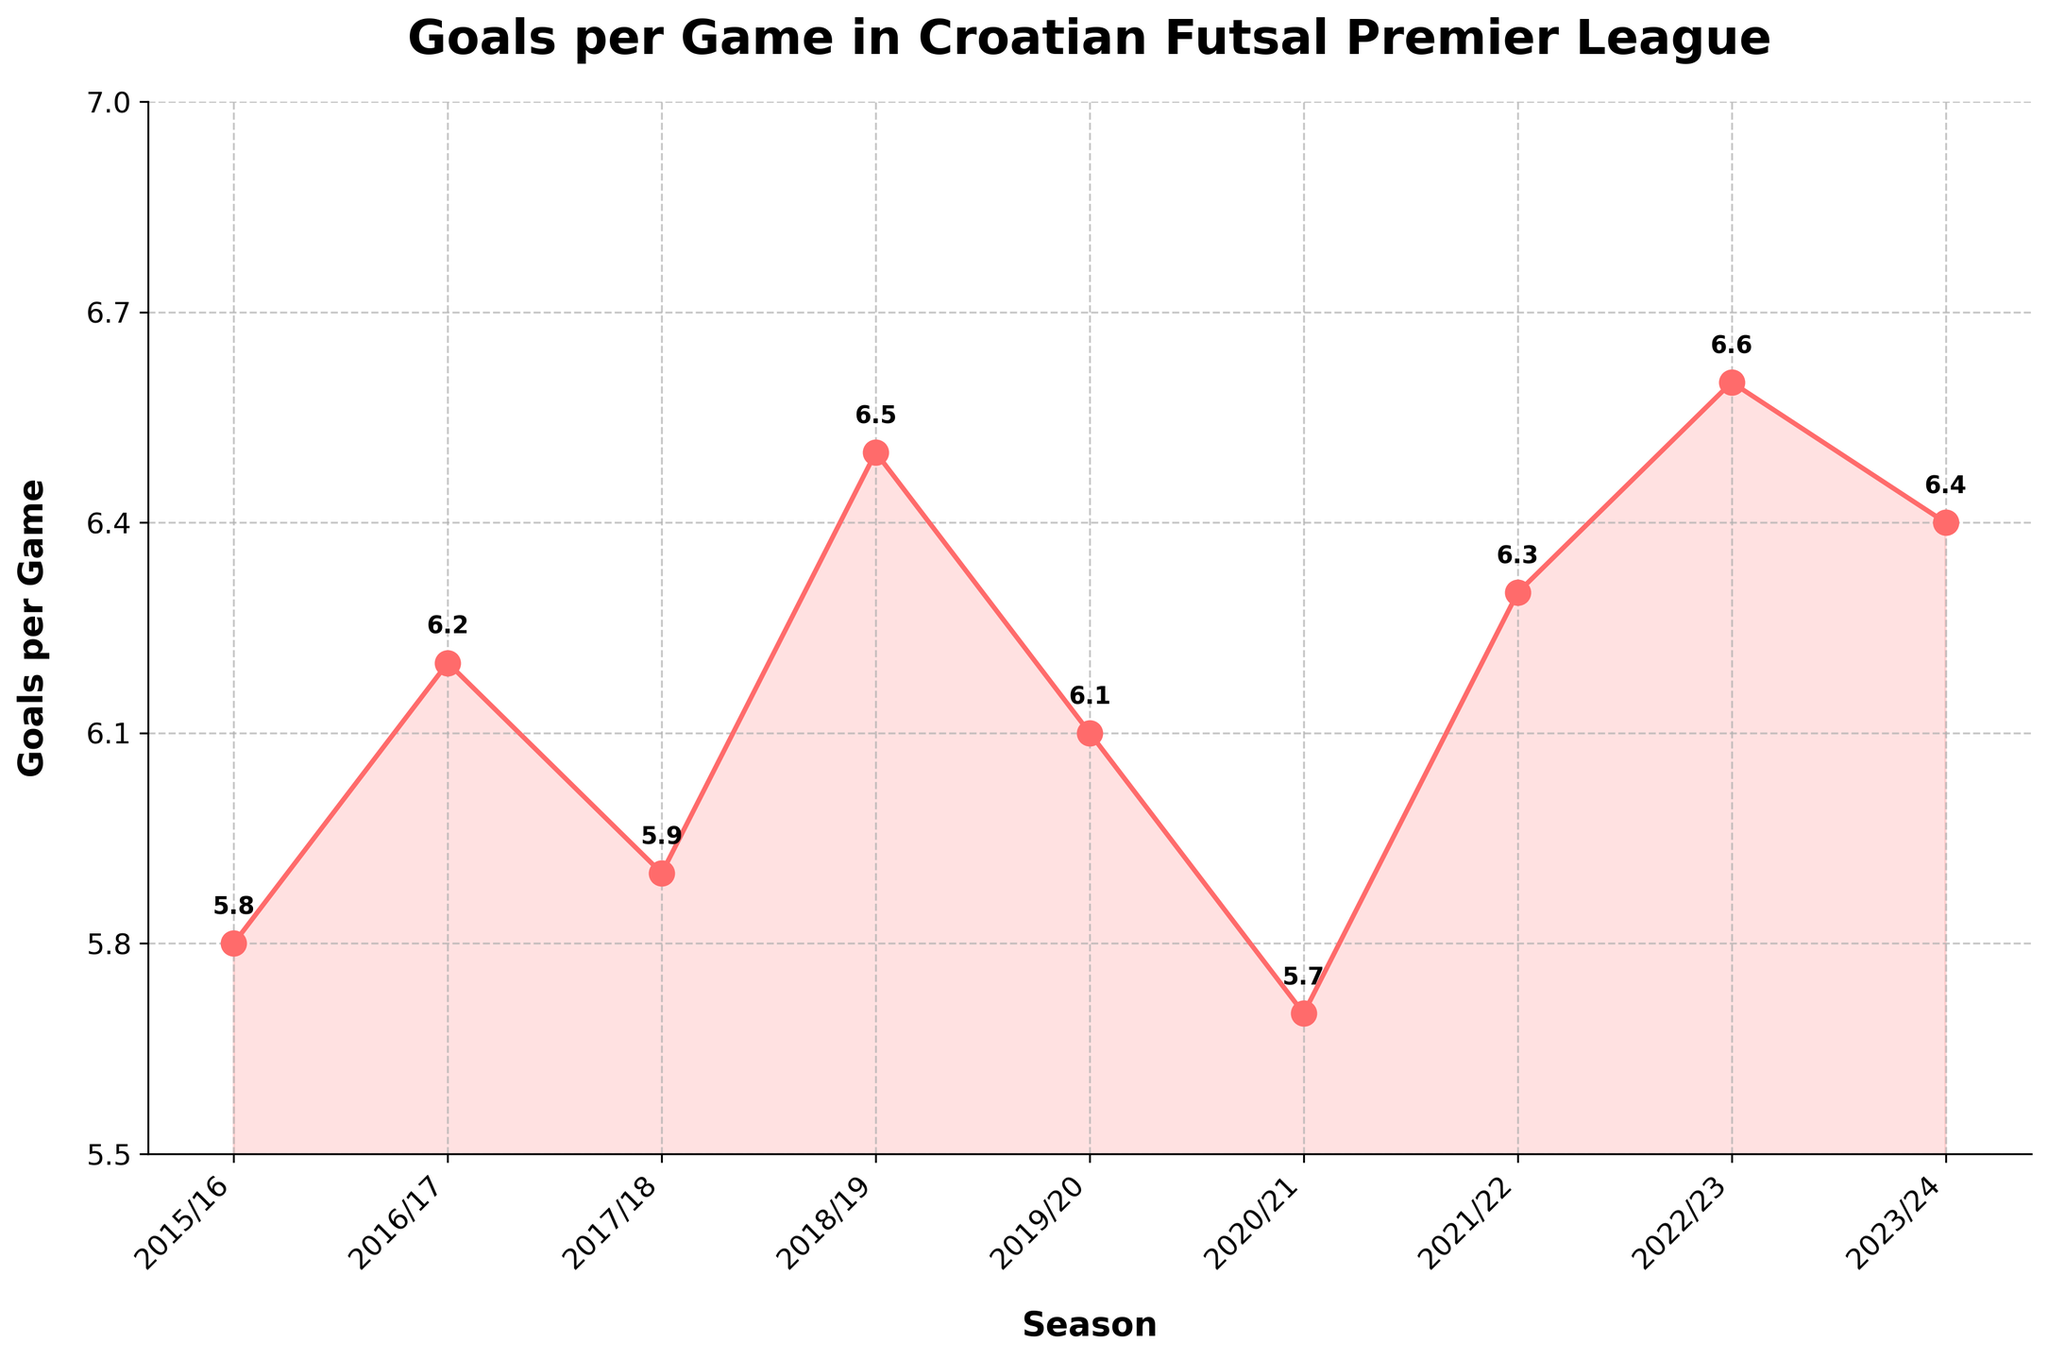What is the average number of goals scored per game in the seasons from 2015/16 to 2023/24? To find the average, sum the goals per game for each season and then divide by the number of seasons. (5.8 + 6.2 + 5.9 + 6.5 + 6.1 + 5.7 + 6.3 + 6.6 + 6.4) / 9 = 55.5 / 9
Answer: 6.17 In which season was the highest number of goals per game scored? Review the data points on the line chart and find the season with the highest value. 2022/23 has the highest value at 6.6
Answer: 2022/23 How many seasons had a goals per game value greater than 6? Count the number of data points that are above 6 on the chart. 4 seasons (2016/17, 2018/19, 2021/22, 2022/23) have values greater than 6
Answer: 4 Which season had the lowest number of goals per game, and what was the value? Find the season with the lowest data point on the line chart. The lowest value is in 2020/21 with 5.7
Answer: 2020/21, 5.7 How much did the goals per game increase from the 2015/16 season to the 2016/17 season? Subtract the value of the 2015/16 season from the value of the 2016/17 season. 6.2 - 5.8 = 0.4
Answer: 0.4 Between which two seasons is the most significant drop in goals per game observed? Identify all declines between consecutive seasons and find the largest drop. The biggest drop is between 2018/19 and 2019/20 (6.5 to 6.1)
Answer: 2018/19 to 2019/20 What is the range of the number of goals per game across all the covered seasons? Subtract the minimum value from the maximum value in the dataset. 6.6 - 5.7 = 0.9
Answer: 0.9 What is the trend of goals per game from the 2020/21 season to the 2023/24 season? Analyze the values from 2020/21 (5.7) onwards (2021/22: 6.3, 2022/23: 6.6, 2023/24: 6.4), noticing whether they increase, decrease, or stay constant. The trend is generally increasing
Answer: Increasing Did the goals per game in the 2019/20 season exceed those in the 2020/21 season? Compare the values of the two seasons directly. 6.1 (2019/20) > 5.7 (2020/21)
Answer: Yes Which seasons recorded goals per game between 6.0 and 6.5? Identify the seasons whose goals per game values fall within the specified range. The seasons are 2016/17 (6.2), 2019/20 (6.1), 2021/22 (6.3), 2023/24 (6.4)
Answer: 2016/17, 2019/20, 2021/22, 2023/24 